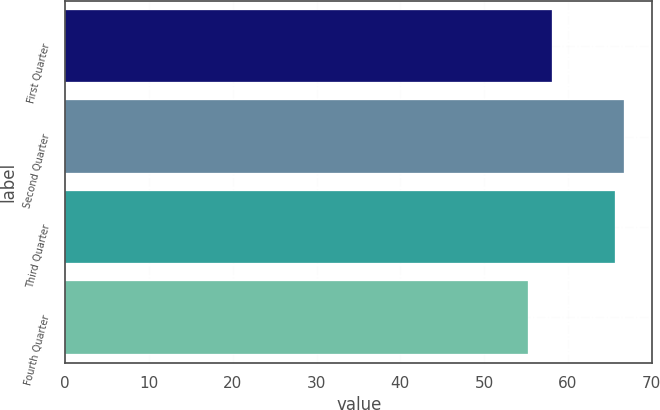<chart> <loc_0><loc_0><loc_500><loc_500><bar_chart><fcel>First Quarter<fcel>Second Quarter<fcel>Third Quarter<fcel>Fourth Quarter<nl><fcel>58.16<fcel>66.74<fcel>65.68<fcel>55.26<nl></chart> 